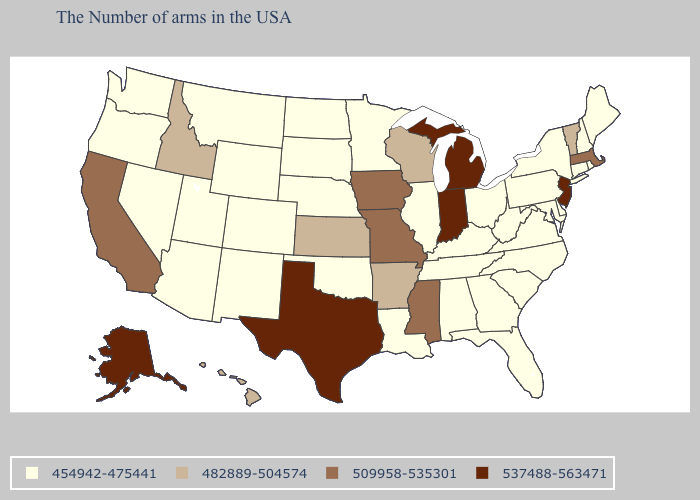Name the states that have a value in the range 509958-535301?
Concise answer only. Massachusetts, Mississippi, Missouri, Iowa, California. Does Ohio have the lowest value in the USA?
Answer briefly. Yes. Which states have the lowest value in the West?
Be succinct. Wyoming, Colorado, New Mexico, Utah, Montana, Arizona, Nevada, Washington, Oregon. What is the value of Oklahoma?
Short answer required. 454942-475441. What is the value of Rhode Island?
Short answer required. 454942-475441. Does the map have missing data?
Give a very brief answer. No. Does Alaska have the highest value in the USA?
Write a very short answer. Yes. What is the highest value in the MidWest ?
Give a very brief answer. 537488-563471. Name the states that have a value in the range 537488-563471?
Be succinct. New Jersey, Michigan, Indiana, Texas, Alaska. What is the highest value in the USA?
Give a very brief answer. 537488-563471. Name the states that have a value in the range 509958-535301?
Short answer required. Massachusetts, Mississippi, Missouri, Iowa, California. Among the states that border Vermont , which have the lowest value?
Write a very short answer. New Hampshire, New York. Name the states that have a value in the range 454942-475441?
Short answer required. Maine, Rhode Island, New Hampshire, Connecticut, New York, Delaware, Maryland, Pennsylvania, Virginia, North Carolina, South Carolina, West Virginia, Ohio, Florida, Georgia, Kentucky, Alabama, Tennessee, Illinois, Louisiana, Minnesota, Nebraska, Oklahoma, South Dakota, North Dakota, Wyoming, Colorado, New Mexico, Utah, Montana, Arizona, Nevada, Washington, Oregon. What is the highest value in the South ?
Concise answer only. 537488-563471. 